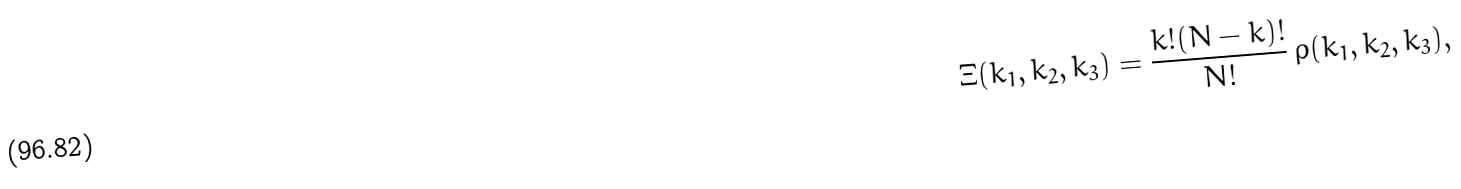Convert formula to latex. <formula><loc_0><loc_0><loc_500><loc_500>\Xi ( k _ { 1 } , k _ { 2 } , k _ { 3 } ) = \frac { k ! ( N - k ) ! } { N ! } \, \rho ( k _ { 1 } , k _ { 2 } , k _ { 3 } ) ,</formula> 